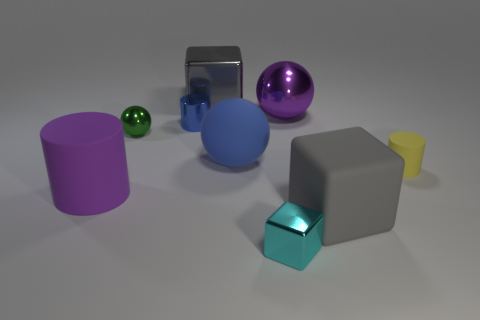Is the big shiny ball the same color as the big rubber sphere? no 